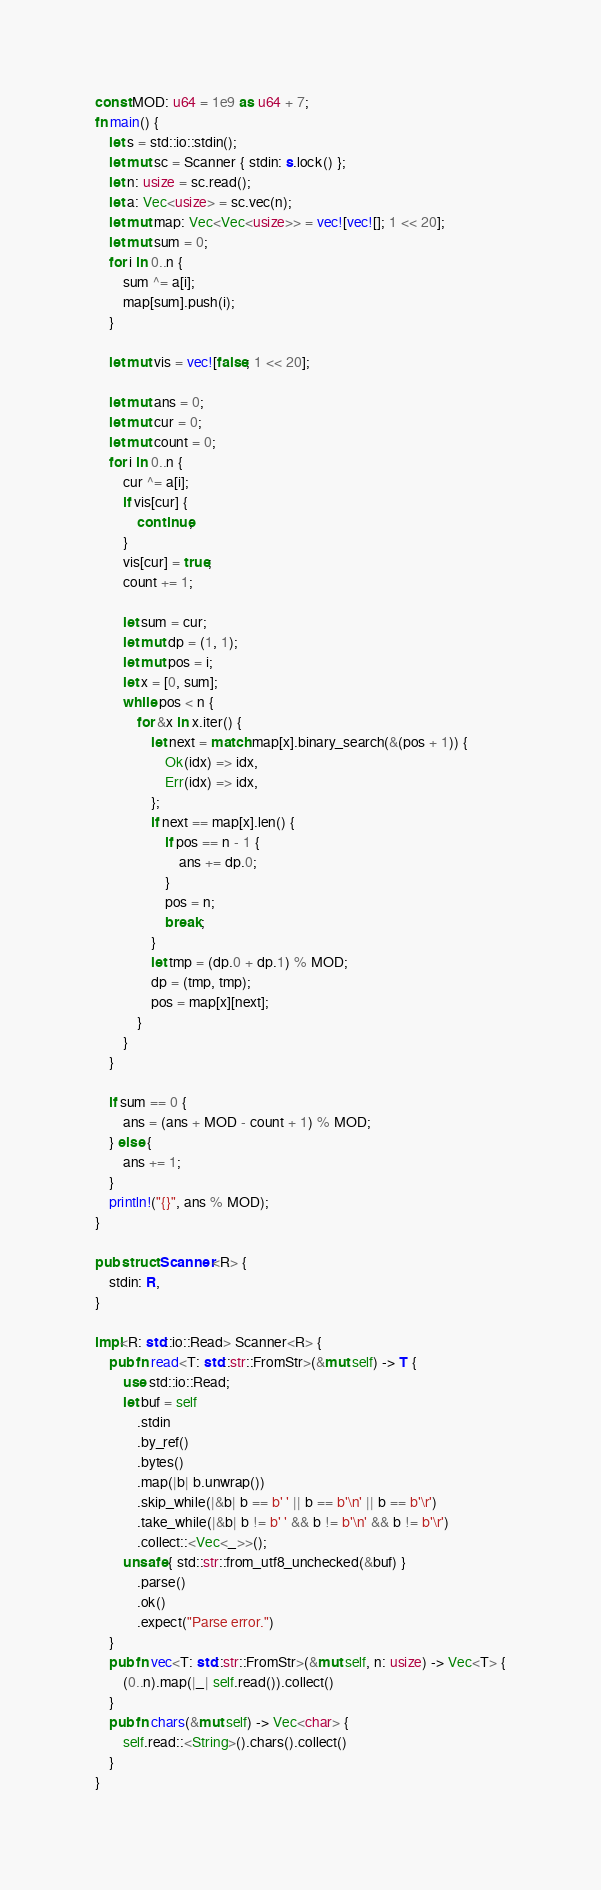<code> <loc_0><loc_0><loc_500><loc_500><_Rust_>const MOD: u64 = 1e9 as u64 + 7;
fn main() {
    let s = std::io::stdin();
    let mut sc = Scanner { stdin: s.lock() };
    let n: usize = sc.read();
    let a: Vec<usize> = sc.vec(n);
    let mut map: Vec<Vec<usize>> = vec![vec![]; 1 << 20];
    let mut sum = 0;
    for i in 0..n {
        sum ^= a[i];
        map[sum].push(i);
    }

    let mut vis = vec![false; 1 << 20];

    let mut ans = 0;
    let mut cur = 0;
    let mut count = 0;
    for i in 0..n {
        cur ^= a[i];
        if vis[cur] {
            continue;
        }
        vis[cur] = true;
        count += 1;

        let sum = cur;
        let mut dp = (1, 1);
        let mut pos = i;
        let x = [0, sum];
        while pos < n {
            for &x in x.iter() {
                let next = match map[x].binary_search(&(pos + 1)) {
                    Ok(idx) => idx,
                    Err(idx) => idx,
                };
                if next == map[x].len() {
                    if pos == n - 1 {
                        ans += dp.0;
                    }
                    pos = n;
                    break;
                }
                let tmp = (dp.0 + dp.1) % MOD;
                dp = (tmp, tmp);
                pos = map[x][next];
            }
        }
    }

    if sum == 0 {
        ans = (ans + MOD - count + 1) % MOD;
    } else {
        ans += 1;
    }
    println!("{}", ans % MOD);
}

pub struct Scanner<R> {
    stdin: R,
}

impl<R: std::io::Read> Scanner<R> {
    pub fn read<T: std::str::FromStr>(&mut self) -> T {
        use std::io::Read;
        let buf = self
            .stdin
            .by_ref()
            .bytes()
            .map(|b| b.unwrap())
            .skip_while(|&b| b == b' ' || b == b'\n' || b == b'\r')
            .take_while(|&b| b != b' ' && b != b'\n' && b != b'\r')
            .collect::<Vec<_>>();
        unsafe { std::str::from_utf8_unchecked(&buf) }
            .parse()
            .ok()
            .expect("Parse error.")
    }
    pub fn vec<T: std::str::FromStr>(&mut self, n: usize) -> Vec<T> {
        (0..n).map(|_| self.read()).collect()
    }
    pub fn chars(&mut self) -> Vec<char> {
        self.read::<String>().chars().collect()
    }
}
</code> 